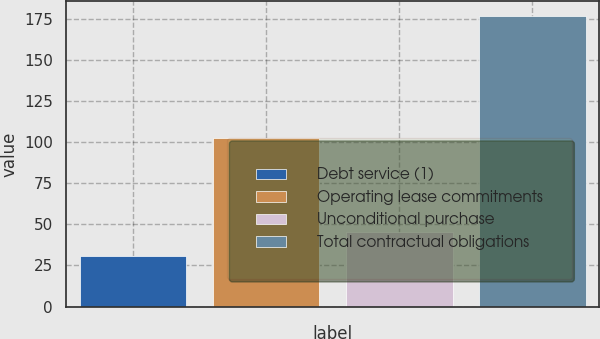<chart> <loc_0><loc_0><loc_500><loc_500><bar_chart><fcel>Debt service (1)<fcel>Operating lease commitments<fcel>Unconditional purchase<fcel>Total contractual obligations<nl><fcel>30.6<fcel>102.2<fcel>45.21<fcel>176.7<nl></chart> 